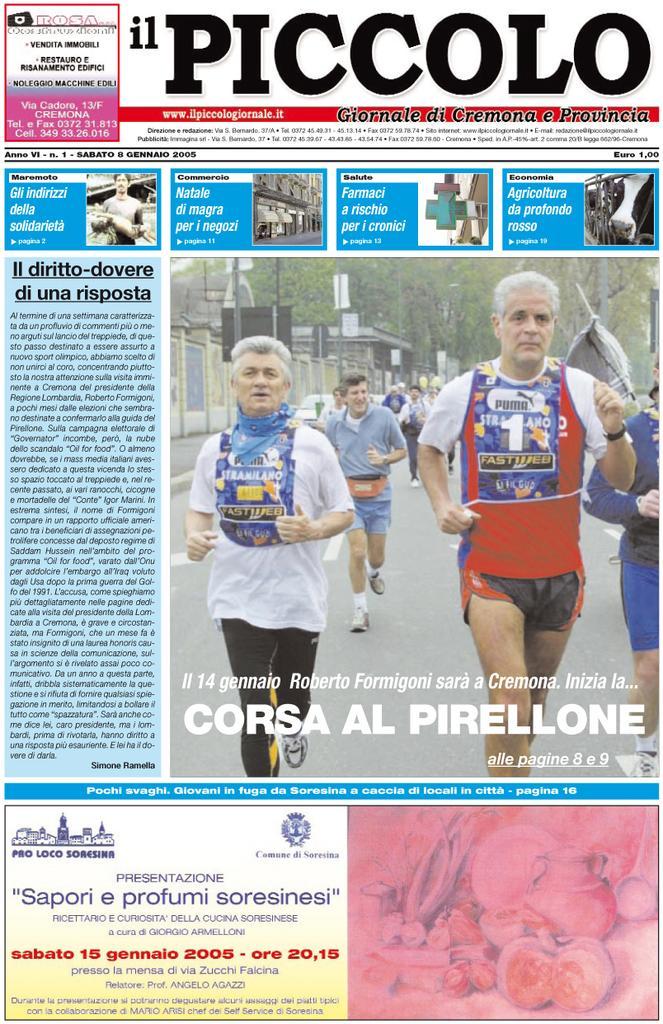Describe this image in one or two sentences. In this image we can see a paper article in which there are images and text. 